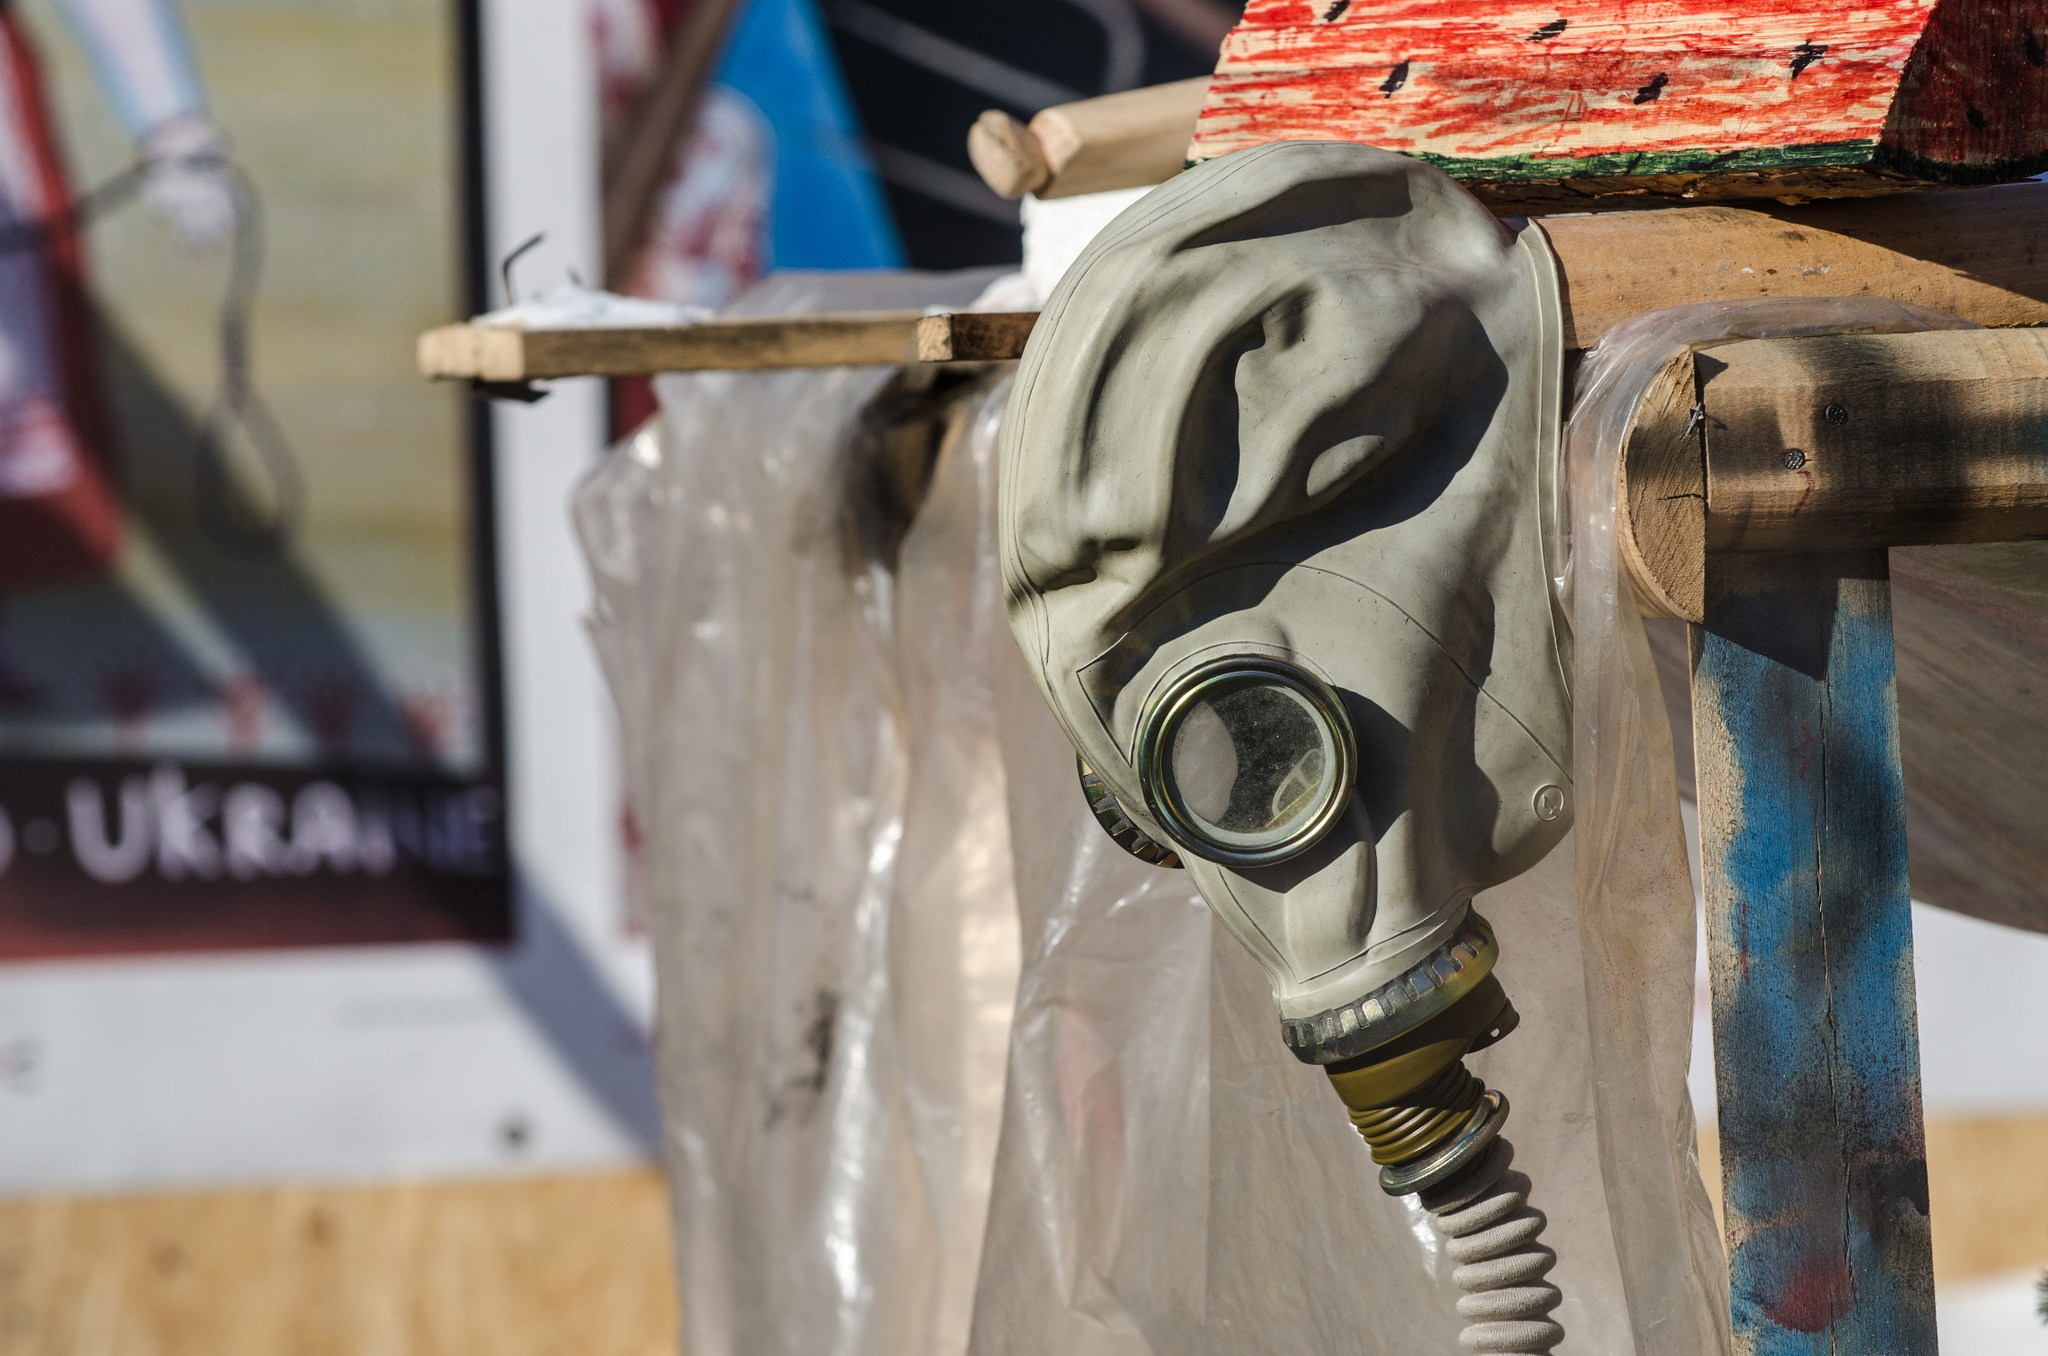Describe the following image. The image captures a close-up view of a green gas mask hanging from a weathered wooden structure, which is adorned with patches of red and blue paint. The gas mask, with its attached hose, is the primary focus of the image. In the background, there's a poster featuring Cyrillic text and a Ukrainian flag, adding a cultural context to the scene. The image is taken from a low angle, further emphasizing the gas mask and its intriguing details. The overall composition suggests a setting that could be a landmark or historical site, possibly related to military history or a significant event. However, without additional information, the exact location or significance of this scene remains uncertain. The code 'sa_15520' doesn't provide enough context to identify the specific landmark. 